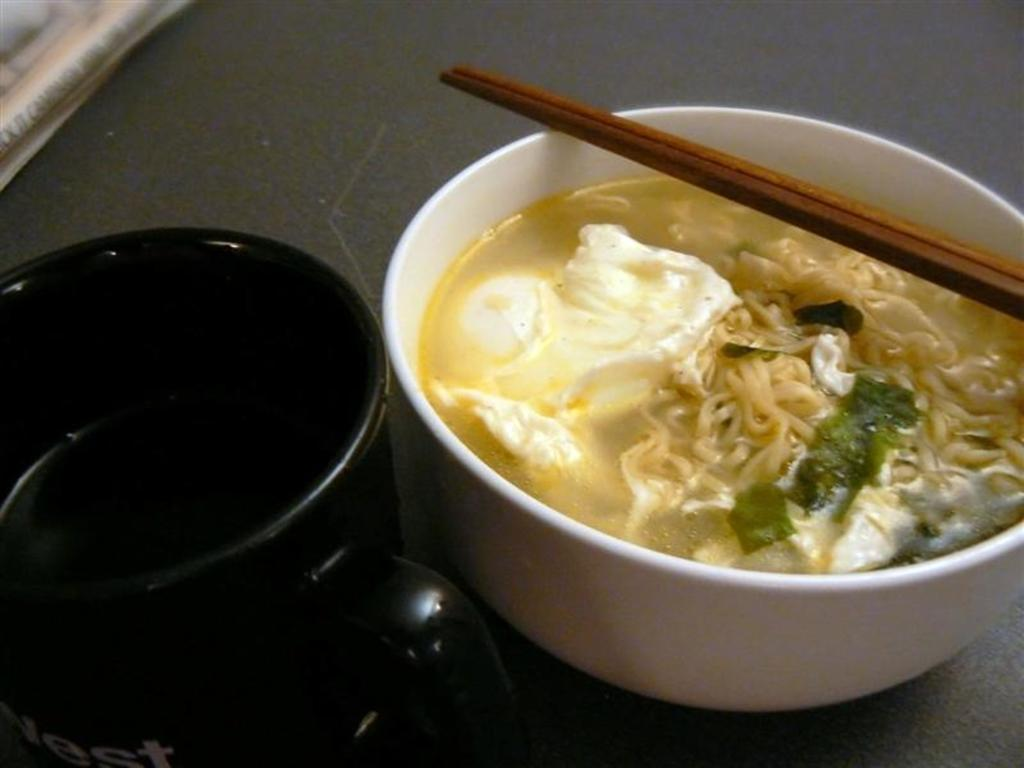How many bowls are in the image? There are two bowls in the image. What is in one of the bowls? One bowl contains soup and noodles. What is unique about the bowl with soup and noodles? A leaf is present in the bowl with soup and noodles. What utensil is placed on top of the bowl? Chopsticks are visible on top of the bowl. What is the color of the bowl with soup and noodles? The bowl is white in color. How many baby mice are crawling on the haircut in the image? There is no haircut or baby mice present in the image. 